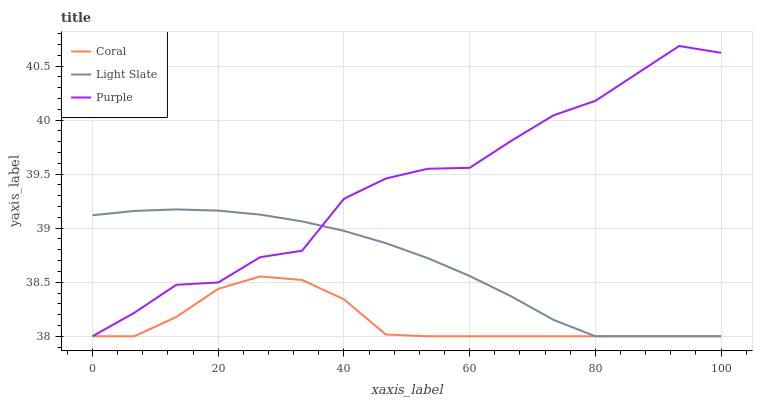Does Coral have the minimum area under the curve?
Answer yes or no. Yes. Does Purple have the maximum area under the curve?
Answer yes or no. Yes. Does Purple have the minimum area under the curve?
Answer yes or no. No. Does Coral have the maximum area under the curve?
Answer yes or no. No. Is Light Slate the smoothest?
Answer yes or no. Yes. Is Purple the roughest?
Answer yes or no. Yes. Is Coral the smoothest?
Answer yes or no. No. Is Coral the roughest?
Answer yes or no. No. Does Light Slate have the lowest value?
Answer yes or no. Yes. Does Purple have the highest value?
Answer yes or no. Yes. Does Coral have the highest value?
Answer yes or no. No. Does Coral intersect Purple?
Answer yes or no. Yes. Is Coral less than Purple?
Answer yes or no. No. Is Coral greater than Purple?
Answer yes or no. No. 